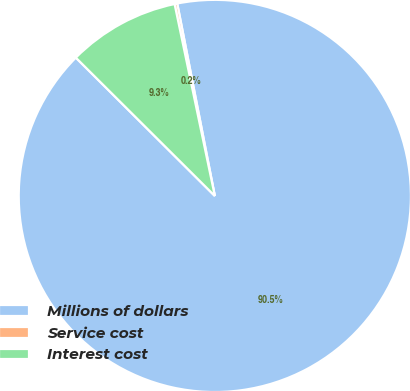Convert chart to OTSL. <chart><loc_0><loc_0><loc_500><loc_500><pie_chart><fcel>Millions of dollars<fcel>Service cost<fcel>Interest cost<nl><fcel>90.52%<fcel>0.22%<fcel>9.25%<nl></chart> 